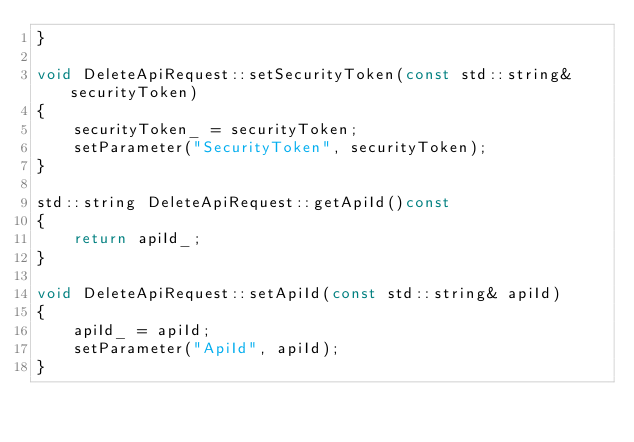Convert code to text. <code><loc_0><loc_0><loc_500><loc_500><_C++_>}

void DeleteApiRequest::setSecurityToken(const std::string& securityToken)
{
	securityToken_ = securityToken;
	setParameter("SecurityToken", securityToken);
}

std::string DeleteApiRequest::getApiId()const
{
	return apiId_;
}

void DeleteApiRequest::setApiId(const std::string& apiId)
{
	apiId_ = apiId;
	setParameter("ApiId", apiId);
}

</code> 